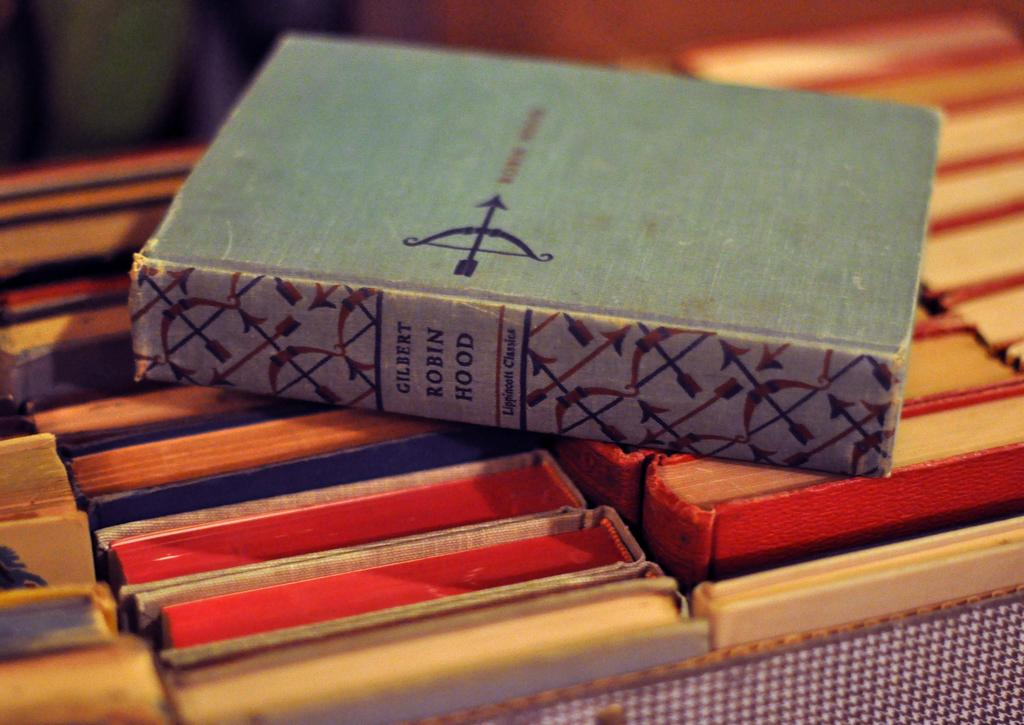Provide a one-sentence caption for the provided image. The book Robin Hood by Gilbert on top of other books. 